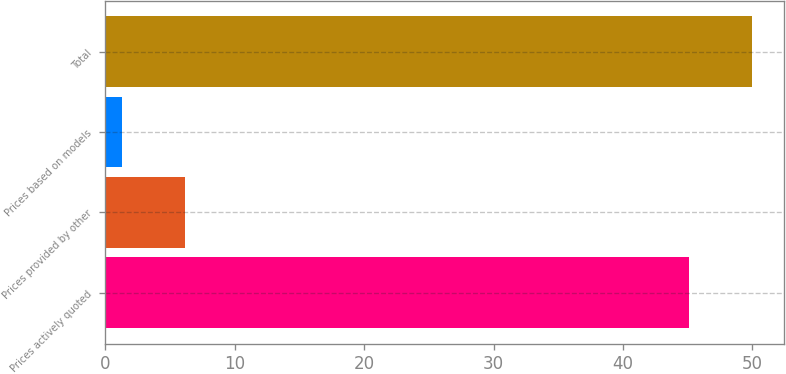Convert chart to OTSL. <chart><loc_0><loc_0><loc_500><loc_500><bar_chart><fcel>Prices actively quoted<fcel>Prices provided by other<fcel>Prices based on models<fcel>Total<nl><fcel>45.1<fcel>6.14<fcel>1.3<fcel>49.94<nl></chart> 